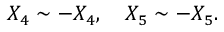<formula> <loc_0><loc_0><loc_500><loc_500>X _ { 4 } \sim - X _ { 4 } , \quad X _ { 5 } \sim - X _ { 5 } .</formula> 